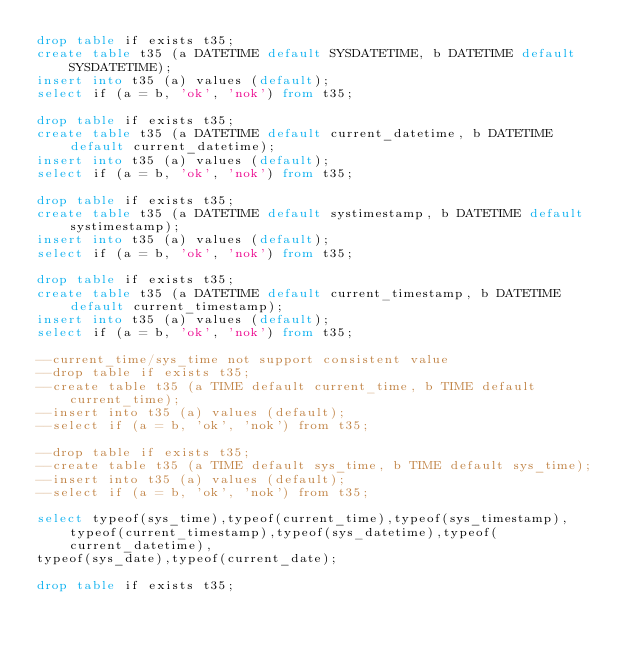Convert code to text. <code><loc_0><loc_0><loc_500><loc_500><_SQL_>drop table if exists t35;
create table t35 (a DATETIME default SYSDATETIME, b DATETIME default SYSDATETIME);
insert into t35 (a) values (default);
select if (a = b, 'ok', 'nok') from t35;

drop table if exists t35;
create table t35 (a DATETIME default current_datetime, b DATETIME default current_datetime);
insert into t35 (a) values (default);
select if (a = b, 'ok', 'nok') from t35;

drop table if exists t35;
create table t35 (a DATETIME default systimestamp, b DATETIME default systimestamp);
insert into t35 (a) values (default);
select if (a = b, 'ok', 'nok') from t35;

drop table if exists t35;
create table t35 (a DATETIME default current_timestamp, b DATETIME default current_timestamp);
insert into t35 (a) values (default);
select if (a = b, 'ok', 'nok') from t35;

--current_time/sys_time not support consistent value
--drop table if exists t35;
--create table t35 (a TIME default current_time, b TIME default current_time);
--insert into t35 (a) values (default);
--select if (a = b, 'ok', 'nok') from t35;

--drop table if exists t35;
--create table t35 (a TIME default sys_time, b TIME default sys_time);
--insert into t35 (a) values (default);
--select if (a = b, 'ok', 'nok') from t35;

select typeof(sys_time),typeof(current_time),typeof(sys_timestamp),typeof(current_timestamp),typeof(sys_datetime),typeof(current_datetime),
typeof(sys_date),typeof(current_date);

drop table if exists t35;
</code> 